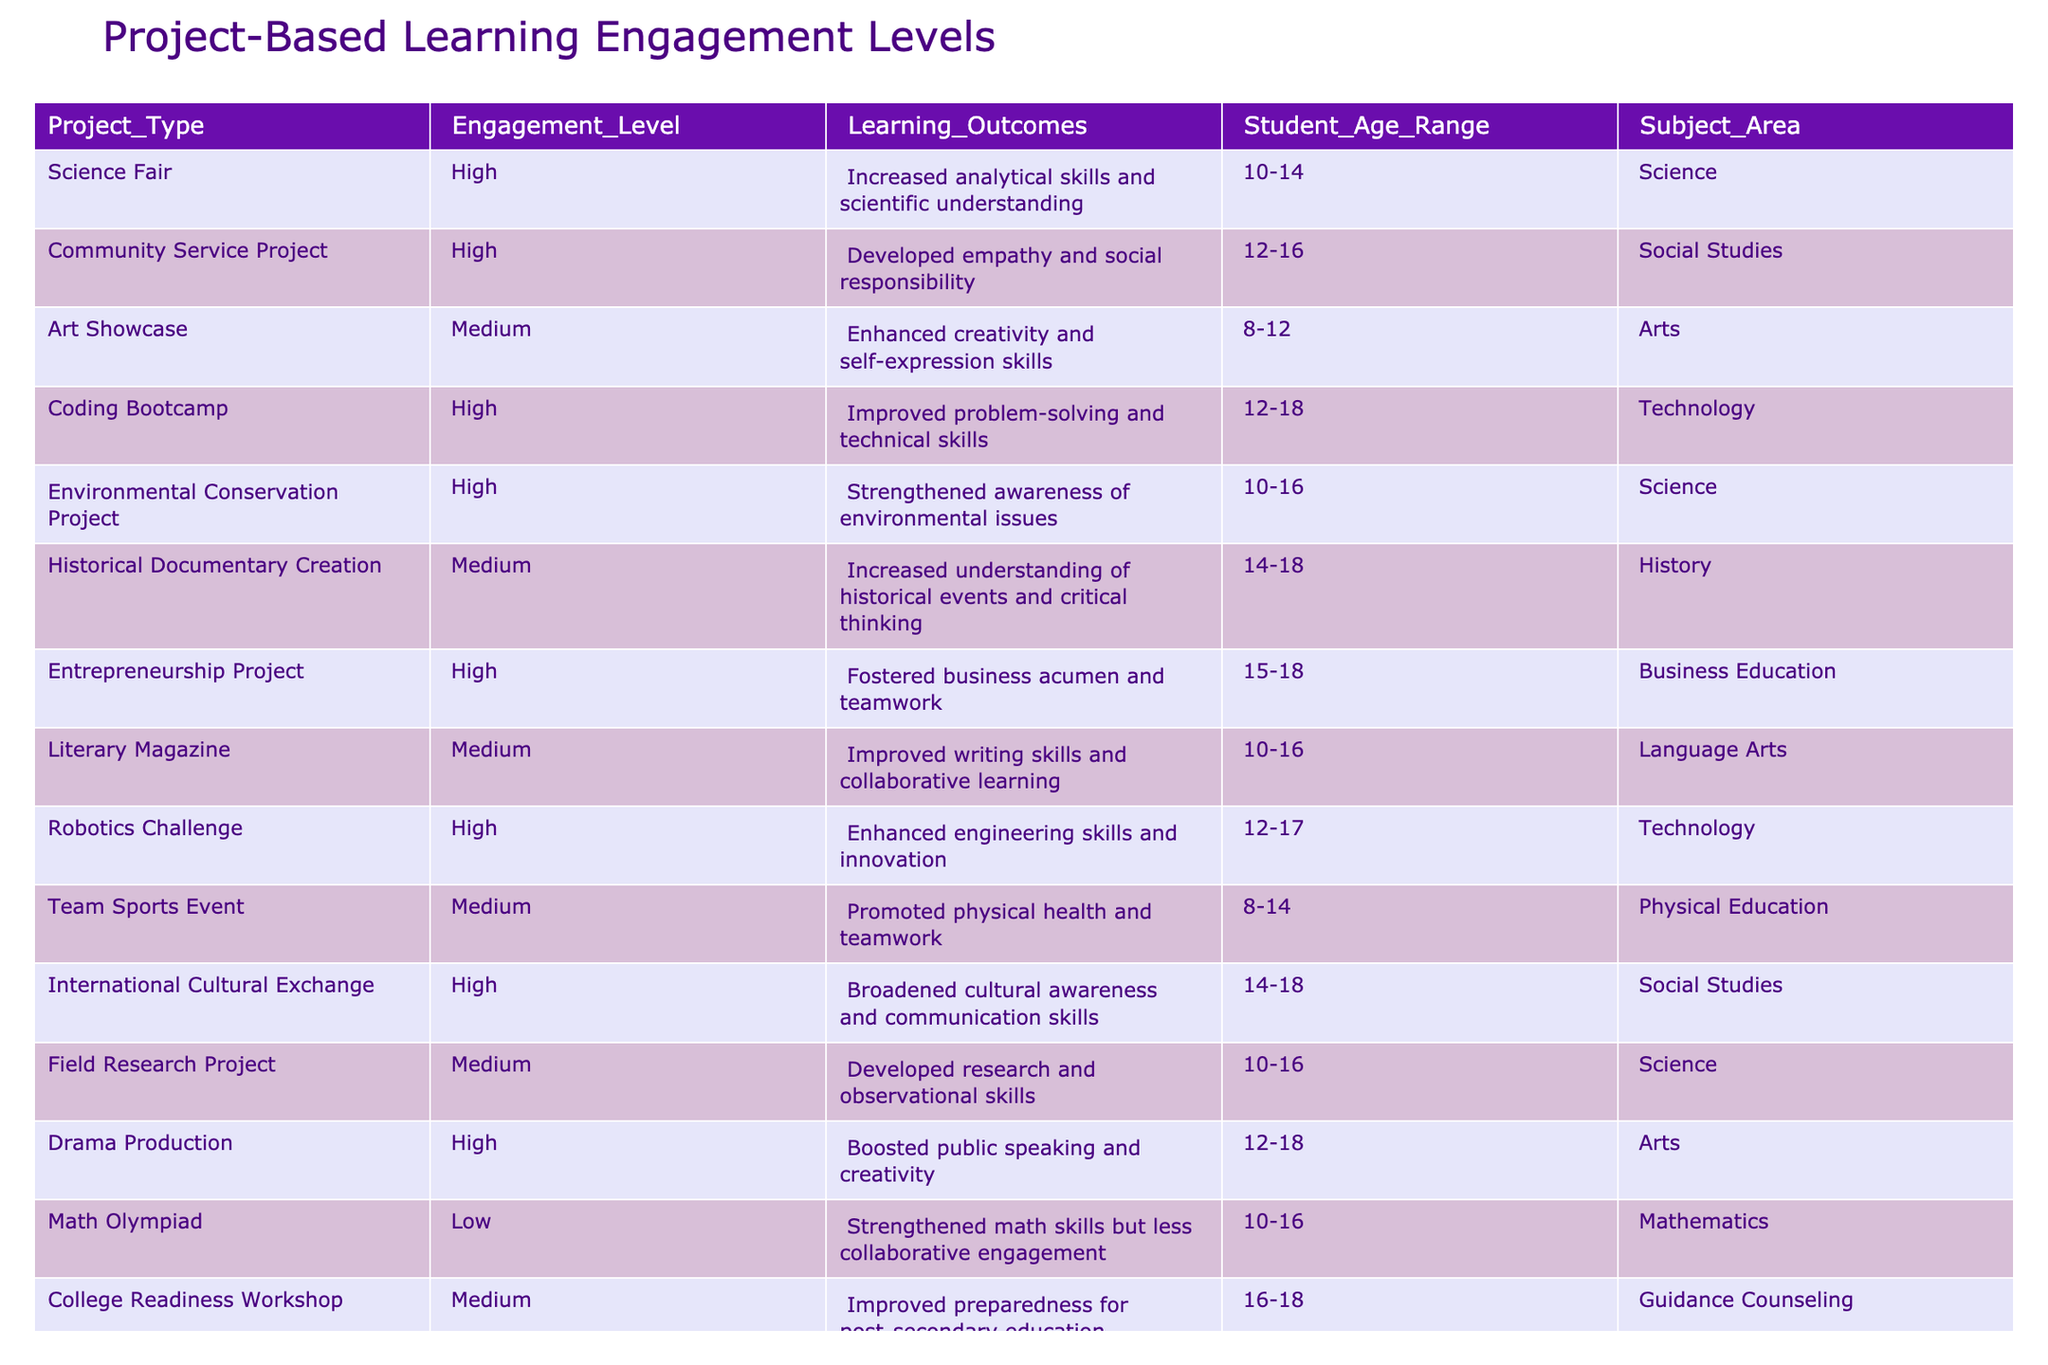What is the engagement level of the Coding Bootcamp project? The engagement level for the Coding Bootcamp project is listed in the table as High.
Answer: High How many project types have a High engagement level? By filtering through the table, we see that there are 6 project types marked with a High engagement level: Science Fair, Community Service Project, Coding Bootcamp, Environmental Conservation Project, Entrepreneurship Project, and Robotics Challenge.
Answer: 6 Is the Literary Magazine project associated with a High engagement level? Looking at the row for the Literary Magazine project, the engagement level is marked as Medium, therefore it is not associated with a High engagement level.
Answer: No What is the average age range of projects with Medium engagement levels? The projects with Medium engagement levels are Art Showcase, Historical Documentary Creation, Literary Magazine, Team Sports Event, Field Research Project, and College Readiness Workshop. The age ranges are 8-12, 14-18, 10-16, 8-14, 10-16, and 16-18. Calculating the average: (10+14+10+8+16) / 5 for the minimum age gives 11.6, and (12+18+16+14+18) / 5 for the maximum age gives 15.4. Thus, the average age range is approximately 11.6-15.4.
Answer: 11.6-15.4 How many of the project types are categorized under Technology? The project types categorized under Technology are Coding Bootcamp and Robotics Challenge, making a total of 2 projects.
Answer: 2 What learning outcome is associated with the Drama Production project? Examining the Drama Production row in the table, the associated learning outcome is boosted public speaking and creativity.
Answer: Boosted public speaking and creativity Which subject area has the highest number of projects with a High engagement level? The subject areas with High engagement levels are Science, Social Studies, Technology, and Business Education. Counting them, Science has 2 (Science Fair, Environmental Conservation Project), Social Studies has 2 (Community Service Project, International Cultural Exchange), Technology has 2 (Coding Bootcamp, Robotics Challenge), and Business Education has 1 (Entrepreneurship Project). Therefore, there is a tie among Science, Social Studies, and Technology with 2 projects each.
Answer: Science, Social Studies, and Technology (tie) In general, do projects related to the Arts have a higher engagement level compared to those in Science? The projects in the Arts (Art Showcase, Drama Production) show a Medium (1 project) and High (1 project) level respectively, whereas Science projects (Science Fair, Environmental Conservation Project, Field Research Project) show 2 High levels and 1 Medium level. We conclude that Science has more High engagement levels than Arts, indicating that Science projects tend to engage students more.
Answer: No 